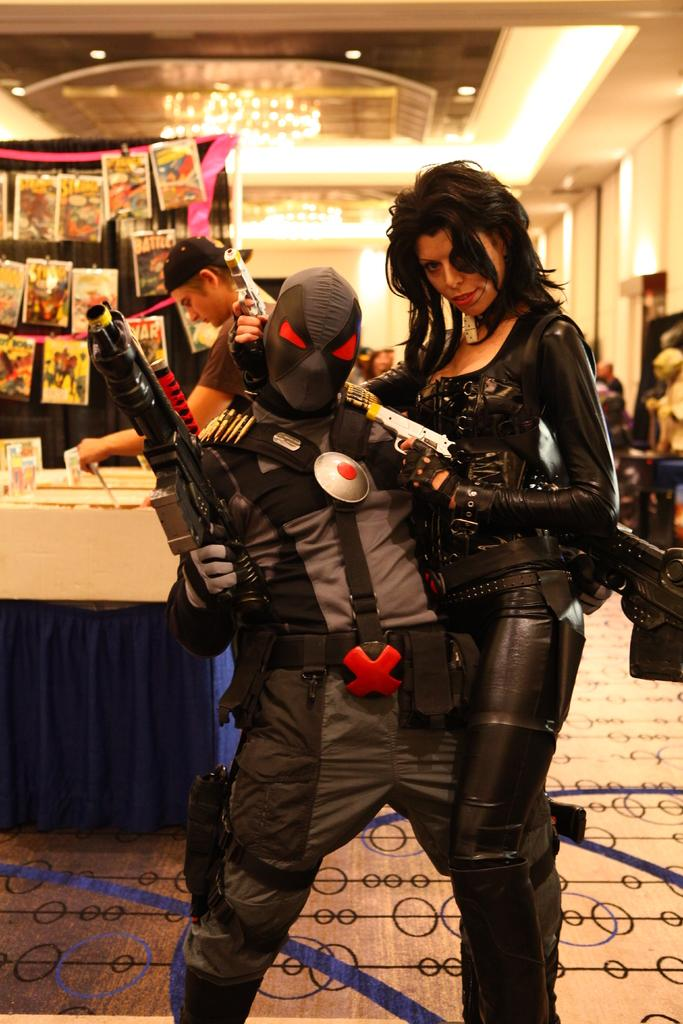How many people are in the image? There are two persons in the center of the image. What are the persons holding in their hands? The persons are holding guns in their hands. What can be seen in the background of the image? There is a stall in the background of the image. What is at the bottom of the image? There is a carpet at the bottom of the image. What type of wound can be seen on the person's arm in the image? There is no wound visible on any person's arm in the image. What flavor of ice cream is being sold at the stall in the image? There is no ice cream or stall selling ice cream in the image. 